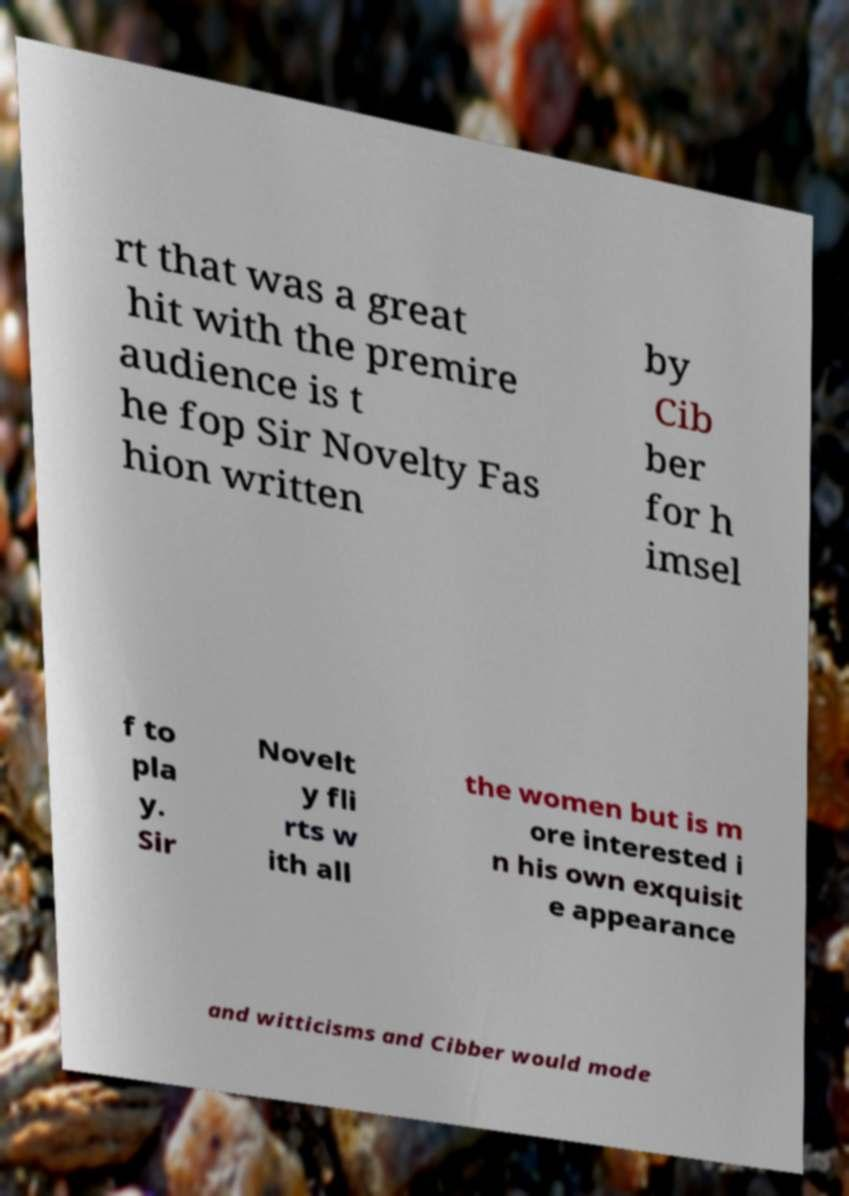Could you extract and type out the text from this image? rt that was a great hit with the premire audience is t he fop Sir Novelty Fas hion written by Cib ber for h imsel f to pla y. Sir Novelt y fli rts w ith all the women but is m ore interested i n his own exquisit e appearance and witticisms and Cibber would mode 